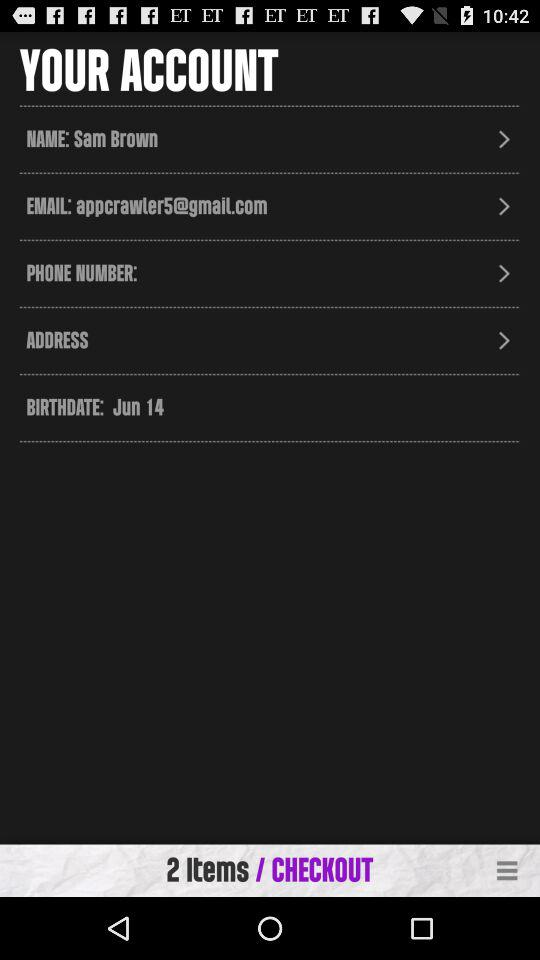How many items are required per checkout? There are 2 items required per checkout. 